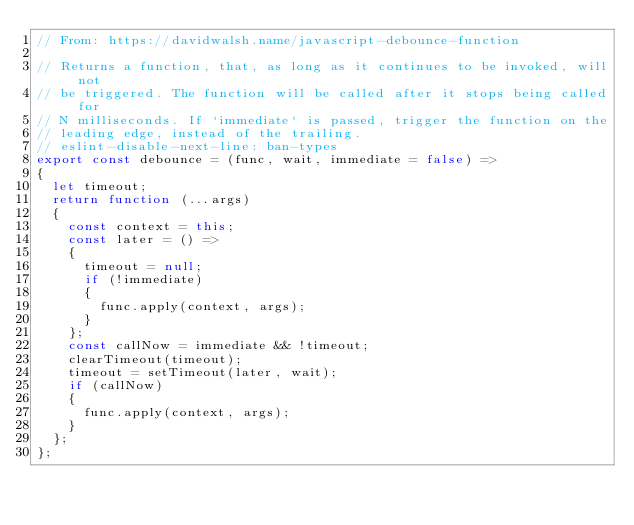Convert code to text. <code><loc_0><loc_0><loc_500><loc_500><_JavaScript_>// From: https://davidwalsh.name/javascript-debounce-function

// Returns a function, that, as long as it continues to be invoked, will not
// be triggered. The function will be called after it stops being called for
// N milliseconds. If `immediate` is passed, trigger the function on the
// leading edge, instead of the trailing.
// eslint-disable-next-line: ban-types
export const debounce = (func, wait, immediate = false) =>
{
	let timeout;
	return function (...args)
	{
		const context = this;
		const later = () =>
		{
			timeout = null;
			if (!immediate)
			{
				func.apply(context, args);
			}
		};
		const callNow = immediate && !timeout;
		clearTimeout(timeout);
		timeout = setTimeout(later, wait);
		if (callNow)
		{
			func.apply(context, args);
		}
	};
};

</code> 